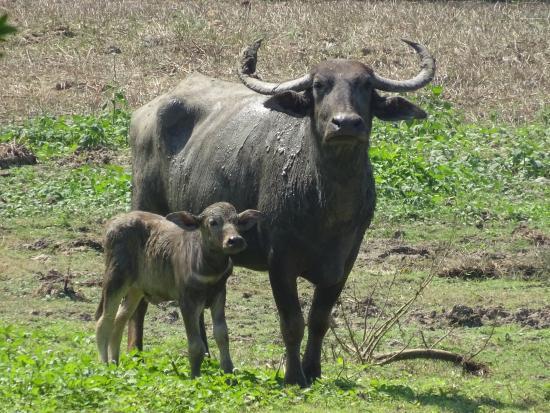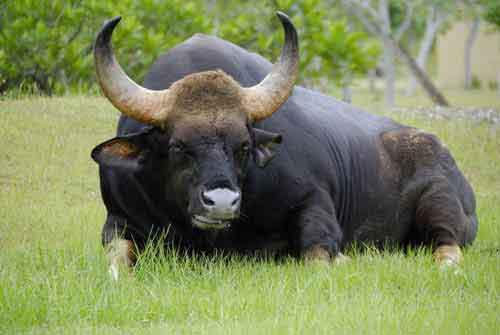The first image is the image on the left, the second image is the image on the right. For the images displayed, is the sentence "An animal is standing." factually correct? Answer yes or no. Yes. The first image is the image on the left, the second image is the image on the right. Evaluate the accuracy of this statement regarding the images: "The left and right image contains the same number of dead bulls.". Is it true? Answer yes or no. No. 